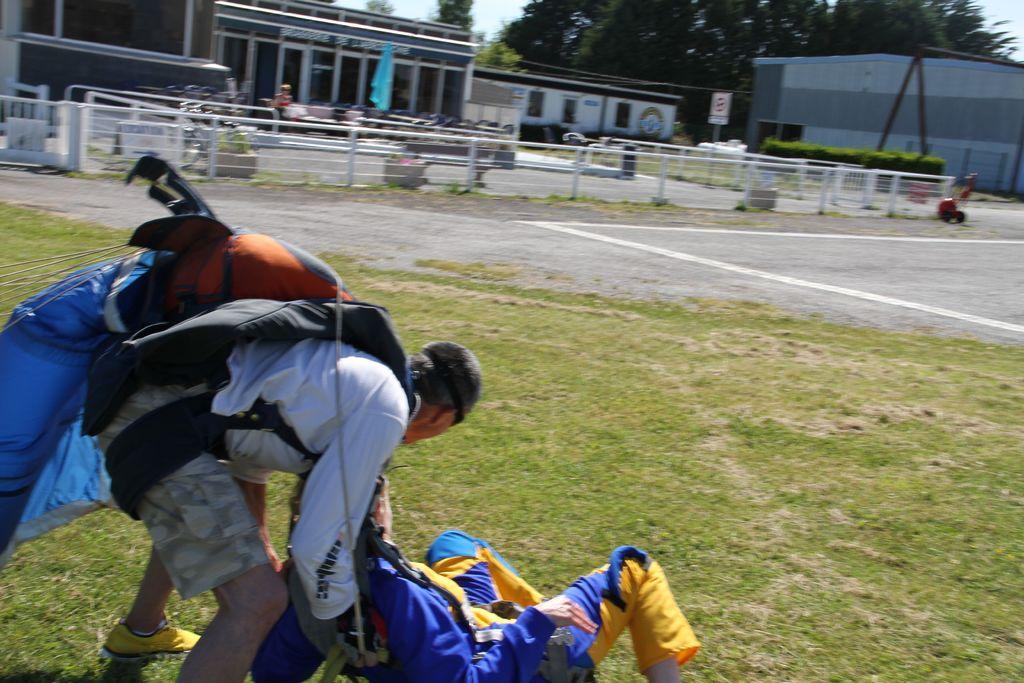In one or two sentences, can you explain what this image depicts? In this picture we can see a man wearing a bag and holding a person. This person is on the grass. We can see some fencing. There is a signboard on the pole. We can see a few buildings and trees in the background. 